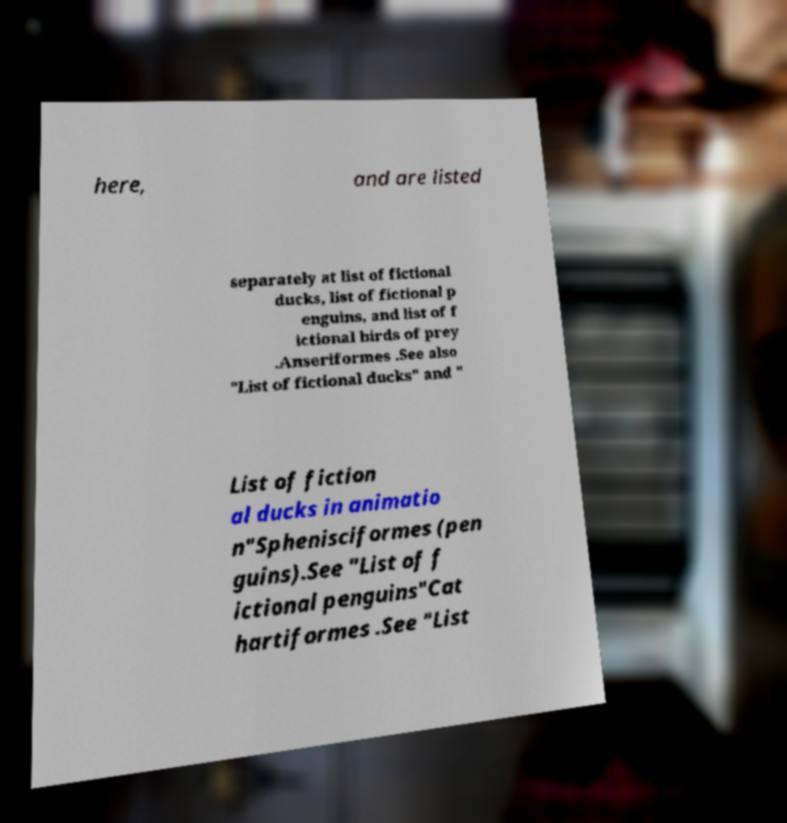Can you accurately transcribe the text from the provided image for me? here, and are listed separately at list of fictional ducks, list of fictional p enguins, and list of f ictional birds of prey .Anseriformes .See also "List of fictional ducks" and " List of fiction al ducks in animatio n"Sphenisciformes (pen guins).See "List of f ictional penguins"Cat hartiformes .See "List 